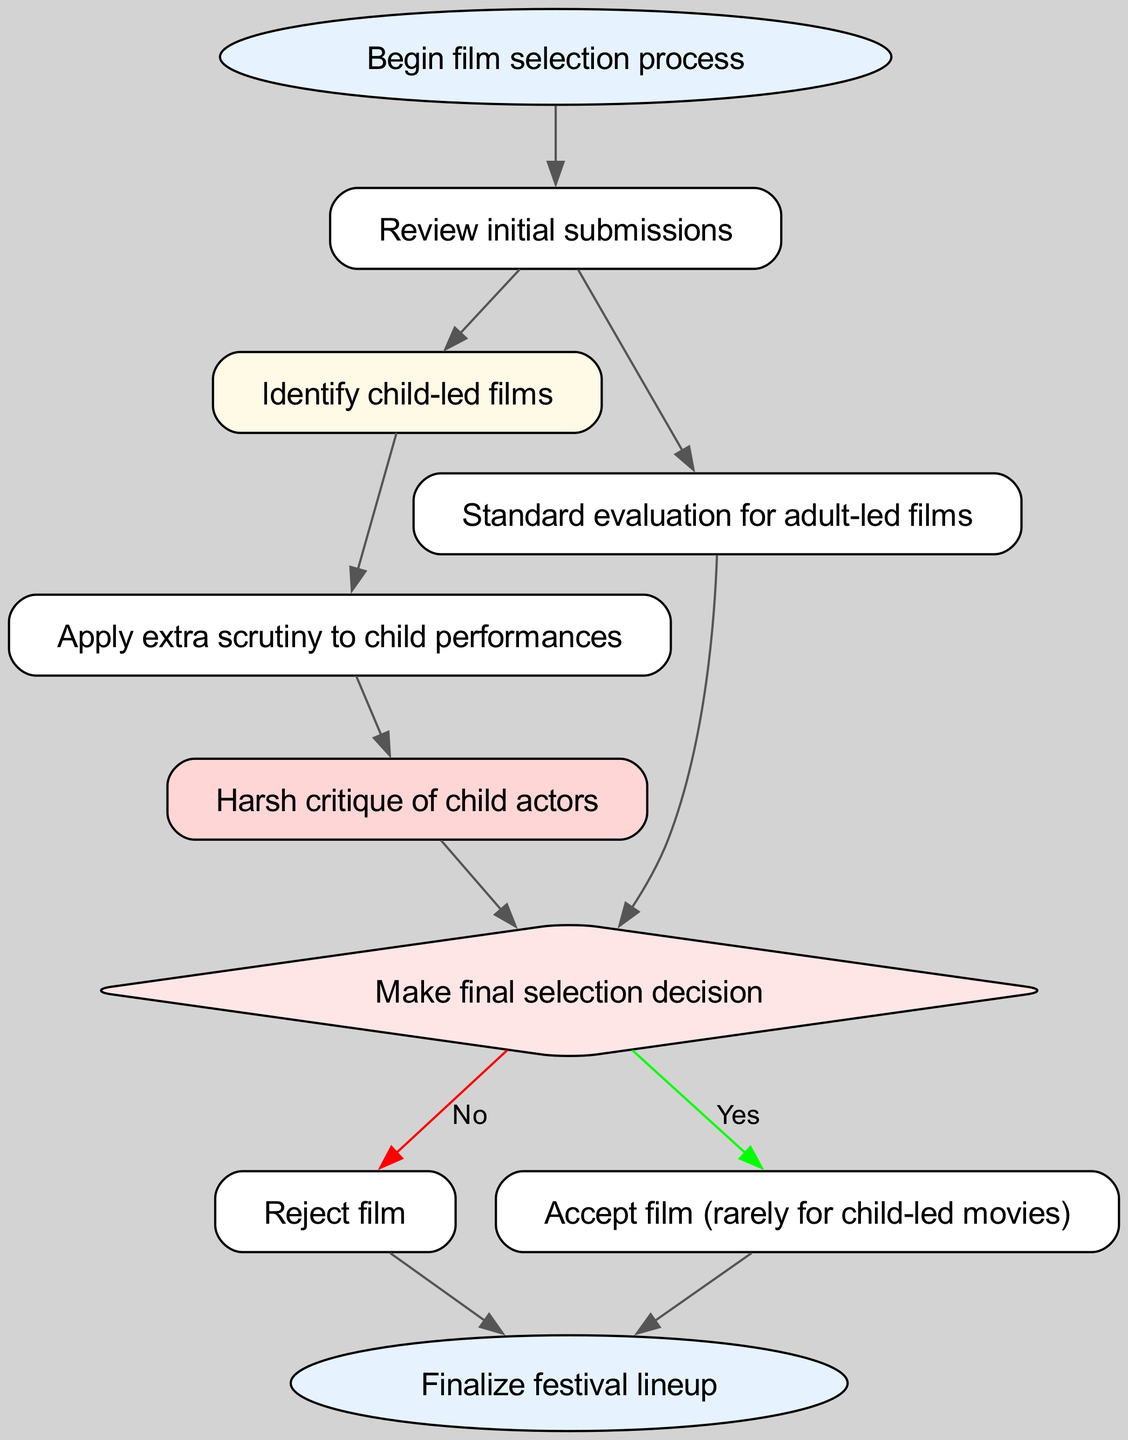What is the first step in the film selection process? The diagram indicates that the first step in the process is to "Begin film selection process." This is the starting point that initiates the entire process described in the diagram.
Answer: Begin film selection process How many types of films are being evaluated? The diagram shows that there are two types of films being evaluated: "child-led films" and "adult-led films." This is evident from the branches leading from the "Review initial submissions" node.
Answer: Two What happens after identifying child-led films? After identifying child-led films, the next step is to "Apply extra scrutiny to child performances." This is a direct connection from the "child-led films" node leading to the scrutiny process.
Answer: Apply extra scrutiny to child performances What is the outcome if a film is rejected? If a film is rejected, the next step is to "Finalize festival lineup." This indicates that despite the rejection, the process continues until all films are finalized.
Answer: Finalize festival lineup What is the color indicating the decision node? The color representing the decision node is "light red." This is observed from the diagram, where the decision node stands out with its specific fill color, distinguishing it from other nodes.
Answer: Light red What specific scrutiny is applied to child-led films? The specific scrutiny applied to child-led films is the "Harsh critique of child actors." This is indicated by the direct connection from the scrutiny step to the critique step.
Answer: Harsh critique of child actors What is the final decision point referred to in the diagram? The final decision point in the diagram is labeled as "Make final selection decision." This is the critical point where the fate of the films is determined before moving on to acceptance or rejection.
Answer: Make final selection decision How are child-led films typically treated in the decision process? The diagram notes that child-led films are "Accepted rarely." This indicates that there is a higher threshold for the acceptance of such films, reflecting a harsher evaluation process.
Answer: Accepted rarely What is the next step after a film is accepted? After a film is accepted, the next step is to "Finalize festival lineup." This indicates that acceptance leads to finalizing the details for the festival, as shown in the flow of the diagram.
Answer: Finalize festival lineup 